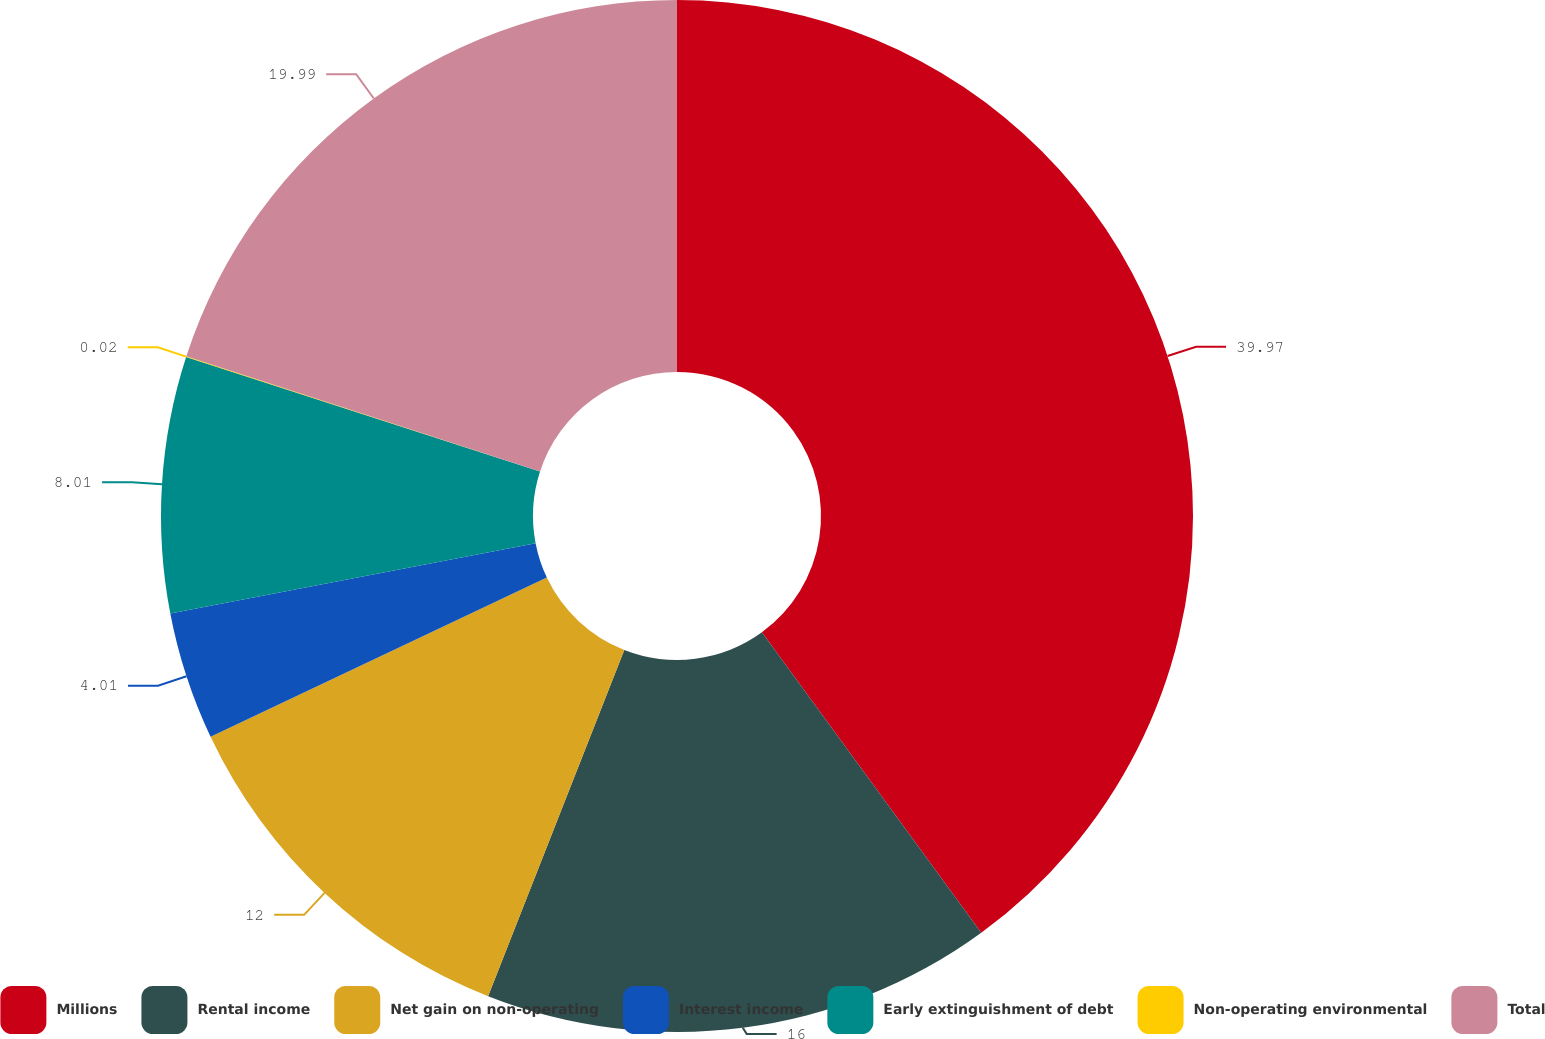Convert chart to OTSL. <chart><loc_0><loc_0><loc_500><loc_500><pie_chart><fcel>Millions<fcel>Rental income<fcel>Net gain on non-operating<fcel>Interest income<fcel>Early extinguishment of debt<fcel>Non-operating environmental<fcel>Total<nl><fcel>39.96%<fcel>16.0%<fcel>12.0%<fcel>4.01%<fcel>8.01%<fcel>0.02%<fcel>19.99%<nl></chart> 